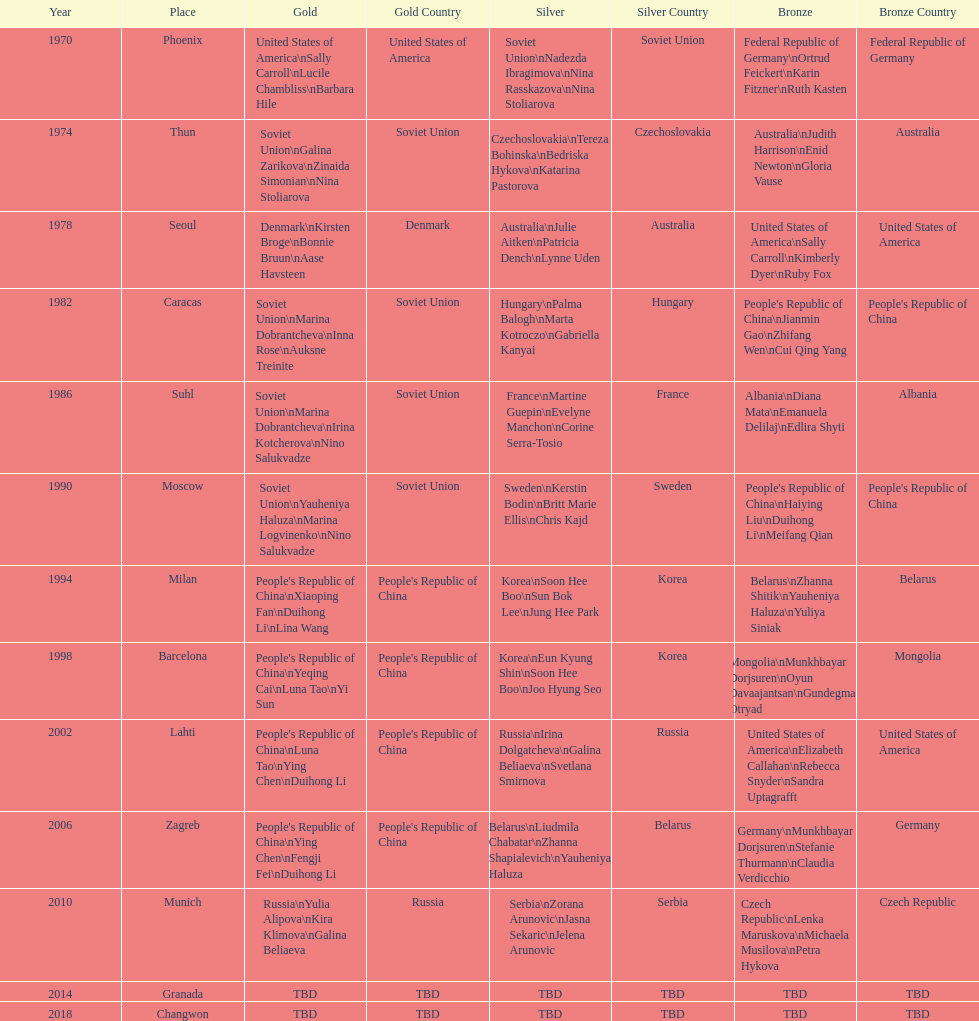Which country is listed the most under the silver column? Korea. 